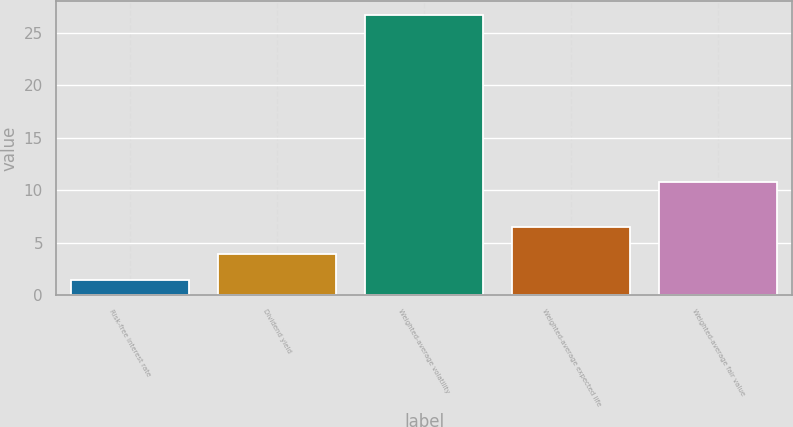Convert chart. <chart><loc_0><loc_0><loc_500><loc_500><bar_chart><fcel>Risk-free interest rate<fcel>Dividend yield<fcel>Weighted-average volatility<fcel>Weighted-average expected life<fcel>Weighted-average fair value<nl><fcel>1.4<fcel>3.93<fcel>26.7<fcel>6.5<fcel>10.82<nl></chart> 